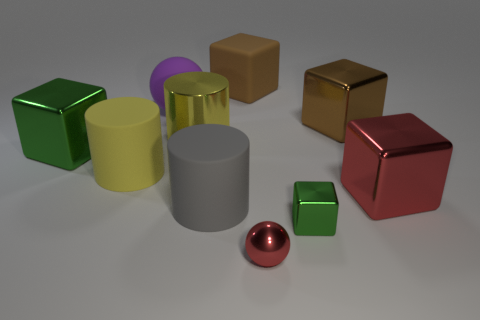Subtract all red cubes. How many cubes are left? 4 Subtract all brown matte blocks. How many blocks are left? 4 Subtract all yellow cubes. Subtract all green cylinders. How many cubes are left? 5 Subtract all cylinders. How many objects are left? 7 Subtract all red cubes. Subtract all gray metallic cylinders. How many objects are left? 9 Add 6 small green blocks. How many small green blocks are left? 7 Add 6 small red balls. How many small red balls exist? 7 Subtract 0 cyan spheres. How many objects are left? 10 